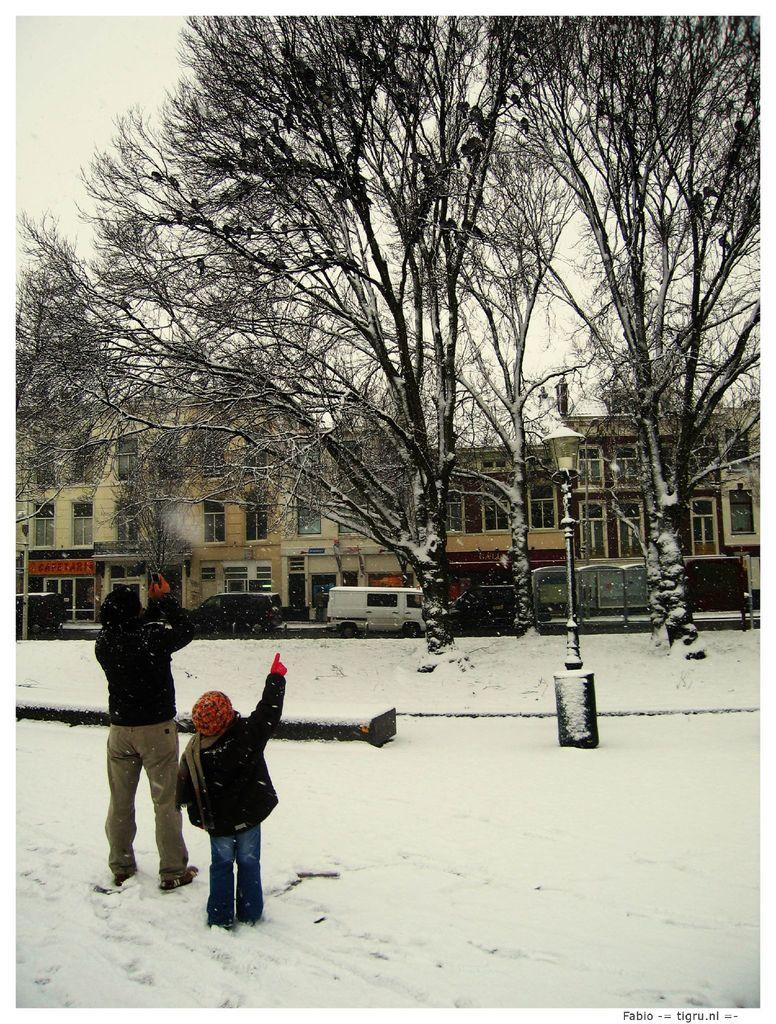How many kids are in the image? There are 2 kids in the image. What is the setting of the image? The kids are standing in the snow. What are the kids looking at in the image? The kids are looking at the trees and the houses. What type of office can be seen in the background of the image? There is no office present in the image; it features 2 kids standing in the snow, looking at trees and houses. 